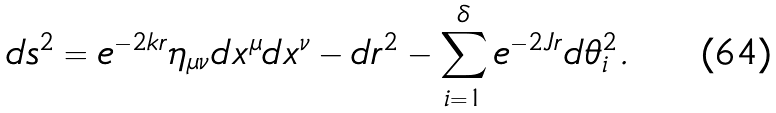Convert formula to latex. <formula><loc_0><loc_0><loc_500><loc_500>d s ^ { 2 } = e ^ { - 2 k r } \eta _ { \mu \nu } d x ^ { \mu } d x ^ { \nu } - d r ^ { 2 } - \sum _ { i = 1 } ^ { \delta } e ^ { - 2 J r } d \theta _ { i } ^ { 2 } .</formula> 